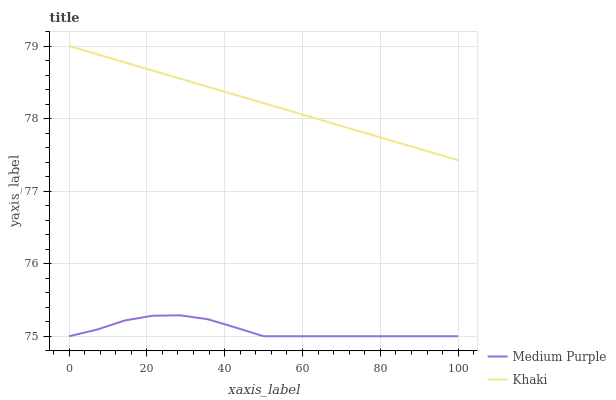Does Medium Purple have the minimum area under the curve?
Answer yes or no. Yes. Does Khaki have the maximum area under the curve?
Answer yes or no. Yes. Does Khaki have the minimum area under the curve?
Answer yes or no. No. Is Khaki the smoothest?
Answer yes or no. Yes. Is Medium Purple the roughest?
Answer yes or no. Yes. Is Khaki the roughest?
Answer yes or no. No. Does Medium Purple have the lowest value?
Answer yes or no. Yes. Does Khaki have the lowest value?
Answer yes or no. No. Does Khaki have the highest value?
Answer yes or no. Yes. Is Medium Purple less than Khaki?
Answer yes or no. Yes. Is Khaki greater than Medium Purple?
Answer yes or no. Yes. Does Medium Purple intersect Khaki?
Answer yes or no. No. 